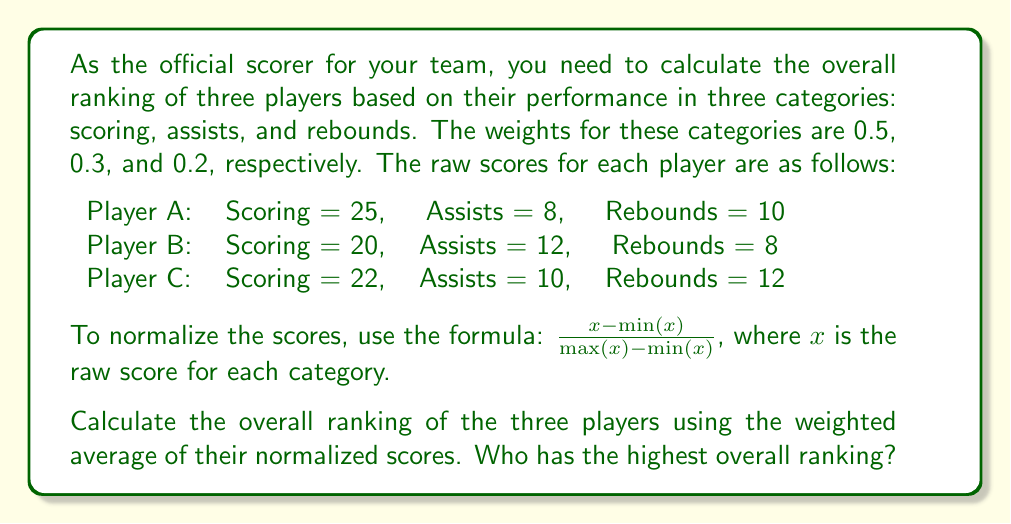Teach me how to tackle this problem. Let's approach this step-by-step:

1. First, we need to normalize the scores for each category using the given formula:

   For Scoring:
   Min = 20, Max = 25
   Player A: $\frac{25 - 20}{25 - 20} = 1$
   Player B: $\frac{20 - 20}{25 - 20} = 0$
   Player C: $\frac{22 - 20}{25 - 20} = 0.4$

   For Assists:
   Min = 8, Max = 12
   Player A: $\frac{8 - 8}{12 - 8} = 0$
   Player B: $\frac{12 - 8}{12 - 8} = 1$
   Player C: $\frac{10 - 8}{12 - 8} = 0.5$

   For Rebounds:
   Min = 8, Max = 12
   Player A: $\frac{10 - 8}{12 - 8} = 0.5$
   Player B: $\frac{8 - 8}{12 - 8} = 0$
   Player C: $\frac{12 - 8}{12 - 8} = 1$

2. Now, we calculate the weighted average for each player:

   Player A: $0.5 \cdot 1 + 0.3 \cdot 0 + 0.2 \cdot 0.5 = 0.6$
   Player B: $0.5 \cdot 0 + 0.3 \cdot 1 + 0.2 \cdot 0 = 0.3$
   Player C: $0.5 \cdot 0.4 + 0.3 \cdot 0.5 + 0.2 \cdot 1 = 0.55$

3. Comparing the weighted averages:
   Player A: 0.6
   Player B: 0.3
   Player C: 0.55

Therefore, Player A has the highest overall ranking.
Answer: Player A 